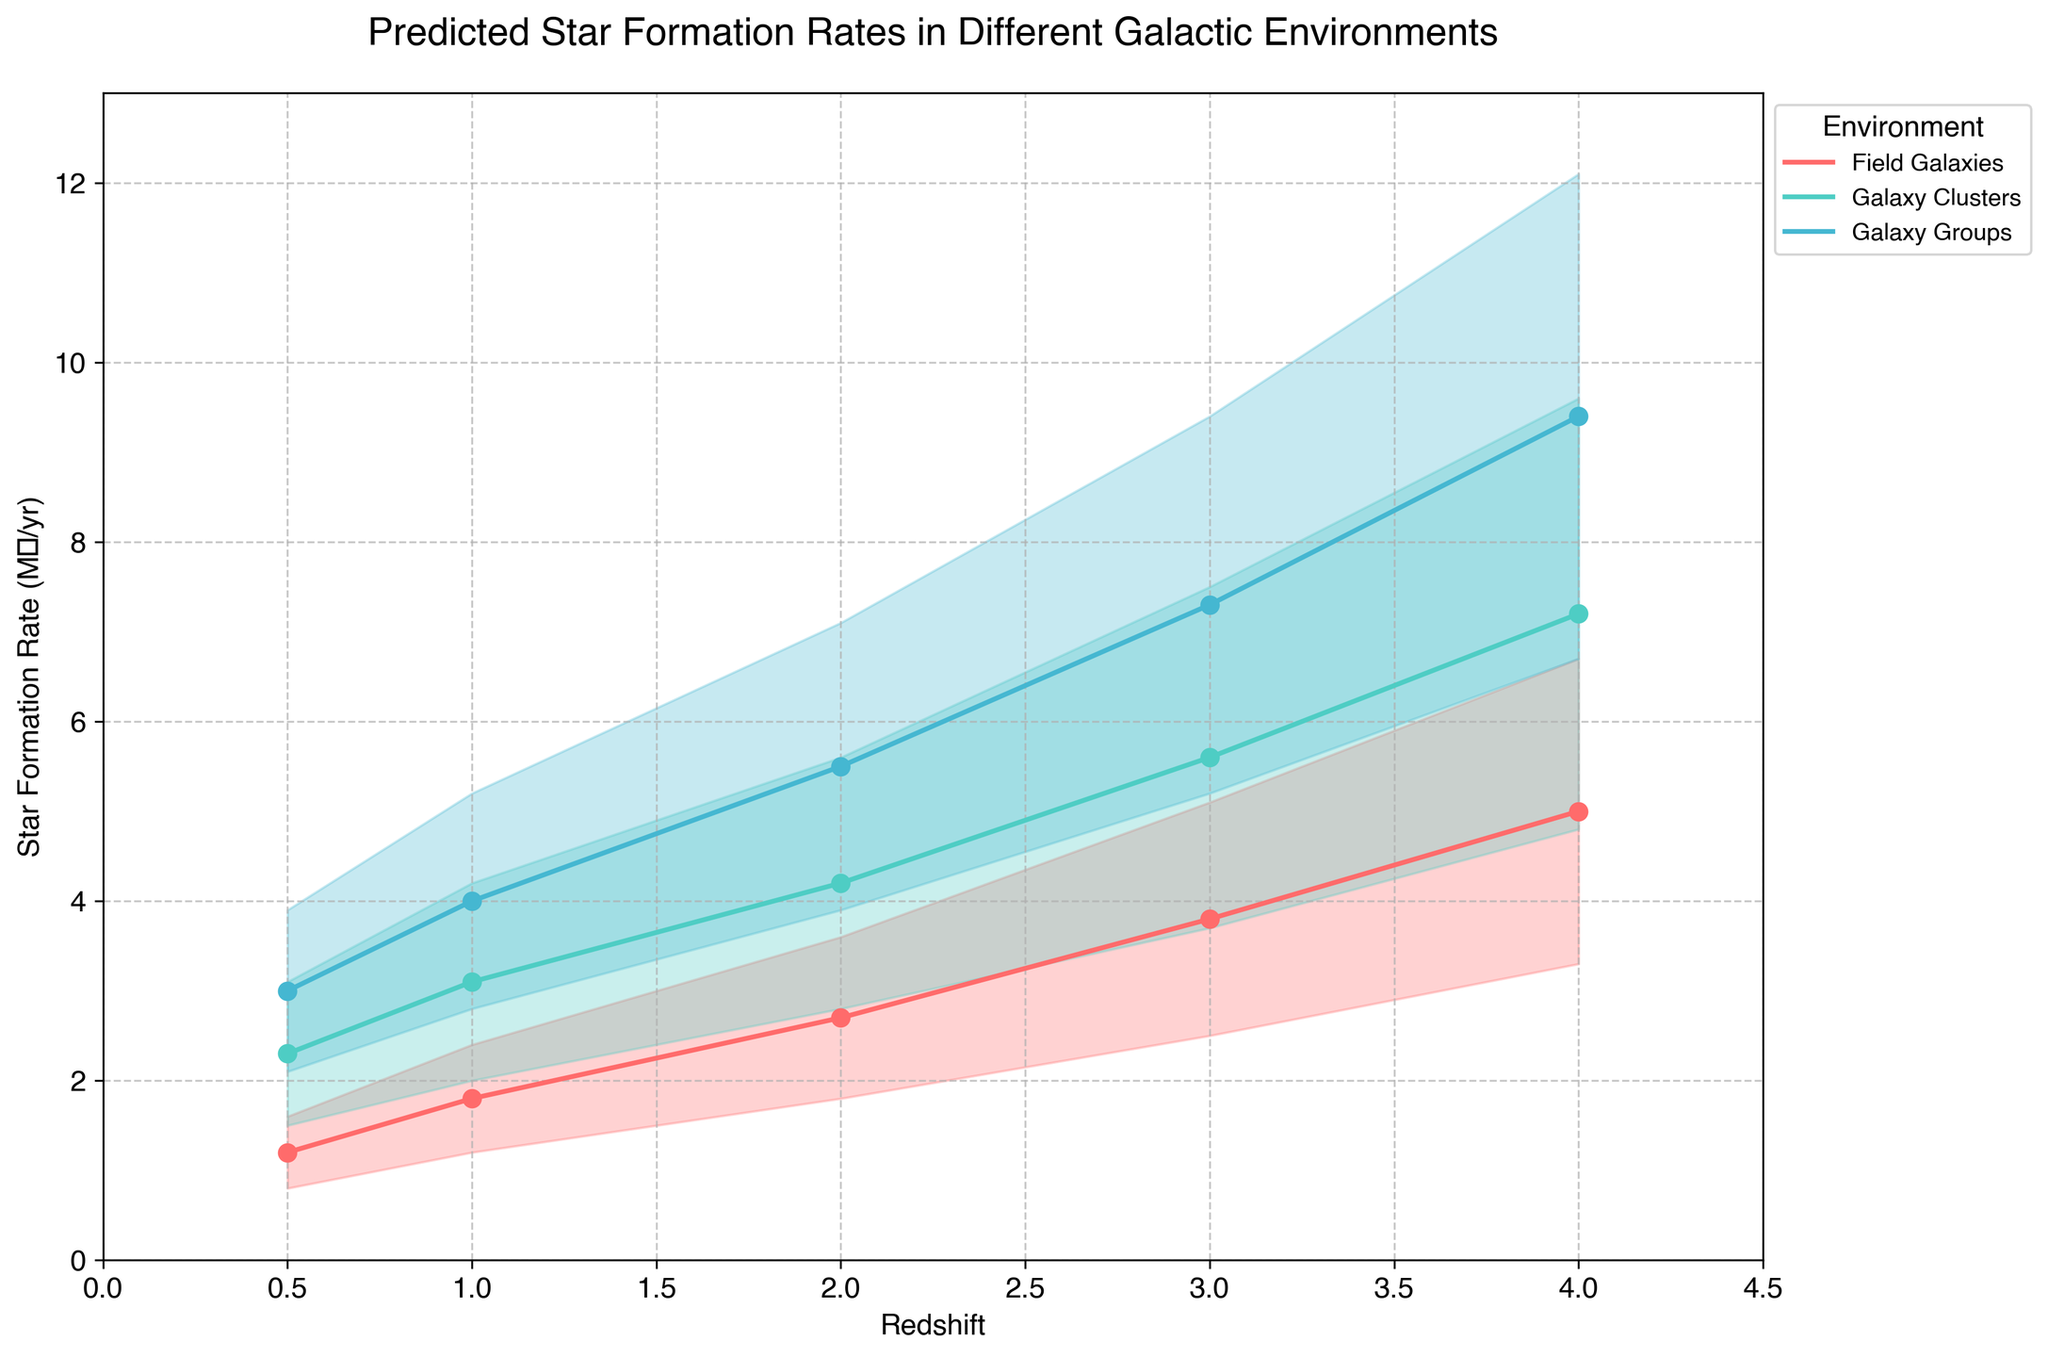What is the title of the figure? The title is located at the top of the figure, providing an overview of the visualized data. It reads "Predicted Star Formation Rates in Different Galactic Environments".
Answer: Predicted Star Formation Rates in Different Galactic Environments What are the units on the y-axis? The label for the y-axis provides the unit, stating "Star Formation Rate (M☉/yr)". This indicates that the rates are in solar masses per year.
Answer: Star Formation Rate (M☉/yr) Which galactic environment shows the highest median star formation rate at redshift 4.0? The figure shows different colored lines for each environment. By looking at the marker points at redshift 4.0, the 'Galaxy Groups' line is highest.
Answer: Galaxy Groups How does the median star formation rate in 'Galaxy Clusters' change from redshift 1.0 to 2.0? Locate the 'Galaxy Clusters' data points on the figure and compare the median values at redshifts 1.0 and 2.0. The values increase from 3.1 to 4.2.
Answer: Increases from 3.1 to 4.2 What is the difference between the high and low star formation rates for 'Field Galaxies' at redshift 3.0? For 'Field Galaxies' at redshift 3.0, find the high and low values (5.1 and 2.5 respectively). Subtract the low value from the high value (5.1 - 2.5).
Answer: 2.6 Which galactic environment shows the least variability in star formation rates at redshift 0.5? Identify the difference between high and low values for each environment at redshift 0.5. 'Field Galaxies' show the smallest range (1.6 - 0.8 = 0.8).
Answer: Field Galaxies What is the pattern of the median star formation rate for 'Galaxy Groups' from redshift 0.5 to 4.0? Observe the median star formation rate for 'Galaxy Groups' across redshifts. It shows an increasing trend from 3.0 to 9.4.
Answer: Increasing trend Which environment has a higher star formation rate variability at redshift 1.0, 'Galaxy Groups' or 'Field Galaxies'? Calculate variability as the difference between high and low values at redshift 1.0. 'Galaxy Groups': 5.2 - 2.8 = 2.4, 'Field Galaxies': 2.4 - 1.2 = 1.2. 'Galaxy Groups' has higher variability.
Answer: Galaxy Groups At which redshift do 'Field Galaxies' show the highest median star formation rate? Compare the median values for 'Field Galaxies' at all redshifts. The highest median value is at redshift 4.0 (5.0).
Answer: 4.0 